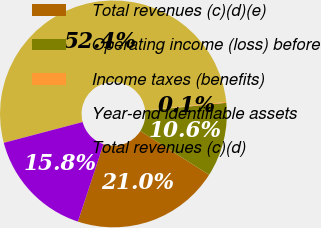Convert chart. <chart><loc_0><loc_0><loc_500><loc_500><pie_chart><fcel>Total revenues (c)(d)(e)<fcel>Operating income (loss) before<fcel>Income taxes (benefits)<fcel>Year-end identifiable assets<fcel>Total revenues (c)(d)<nl><fcel>21.05%<fcel>10.59%<fcel>0.13%<fcel>52.42%<fcel>15.82%<nl></chart> 